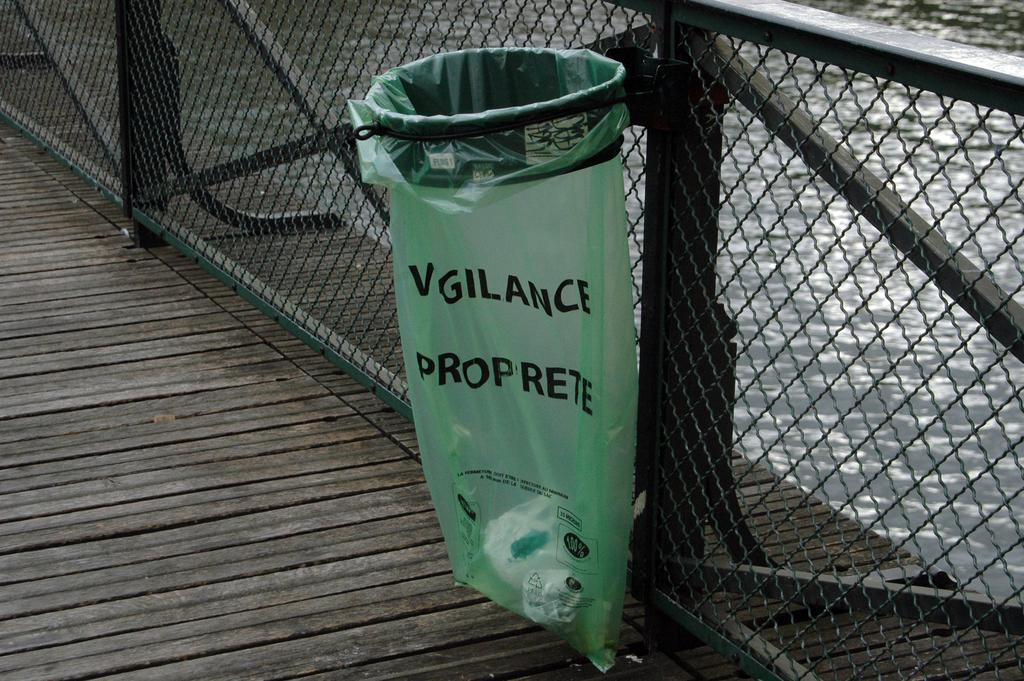Provide a one-sentence caption for the provided image. a green trash can bag that says Vigilance proprete. 